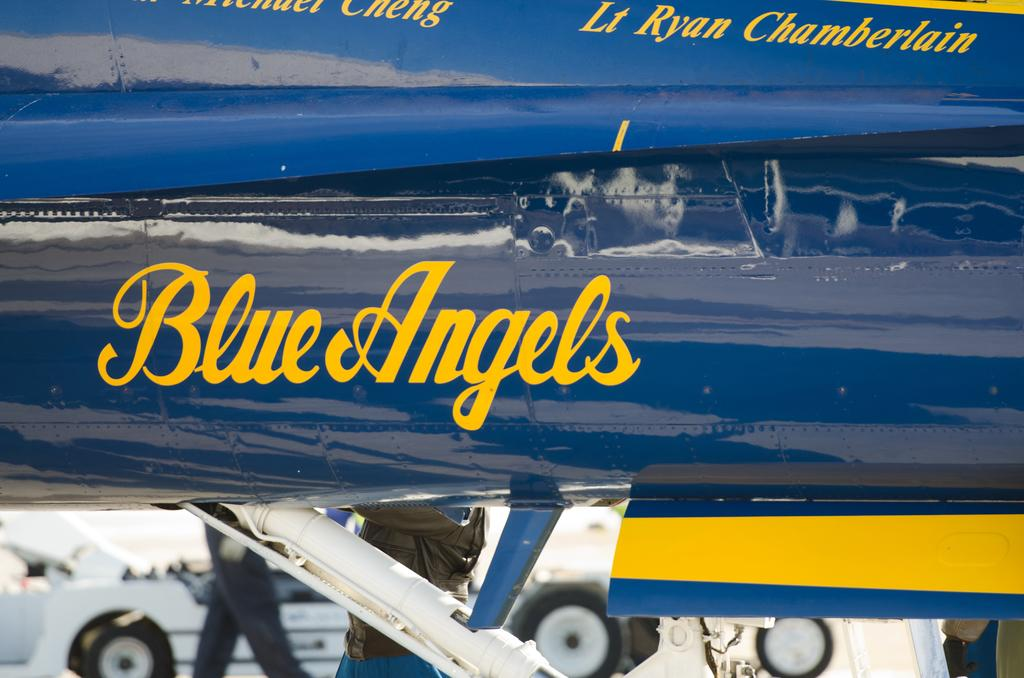<image>
Relay a brief, clear account of the picture shown. a yellow and blue plane with the text blue angels on its side. 